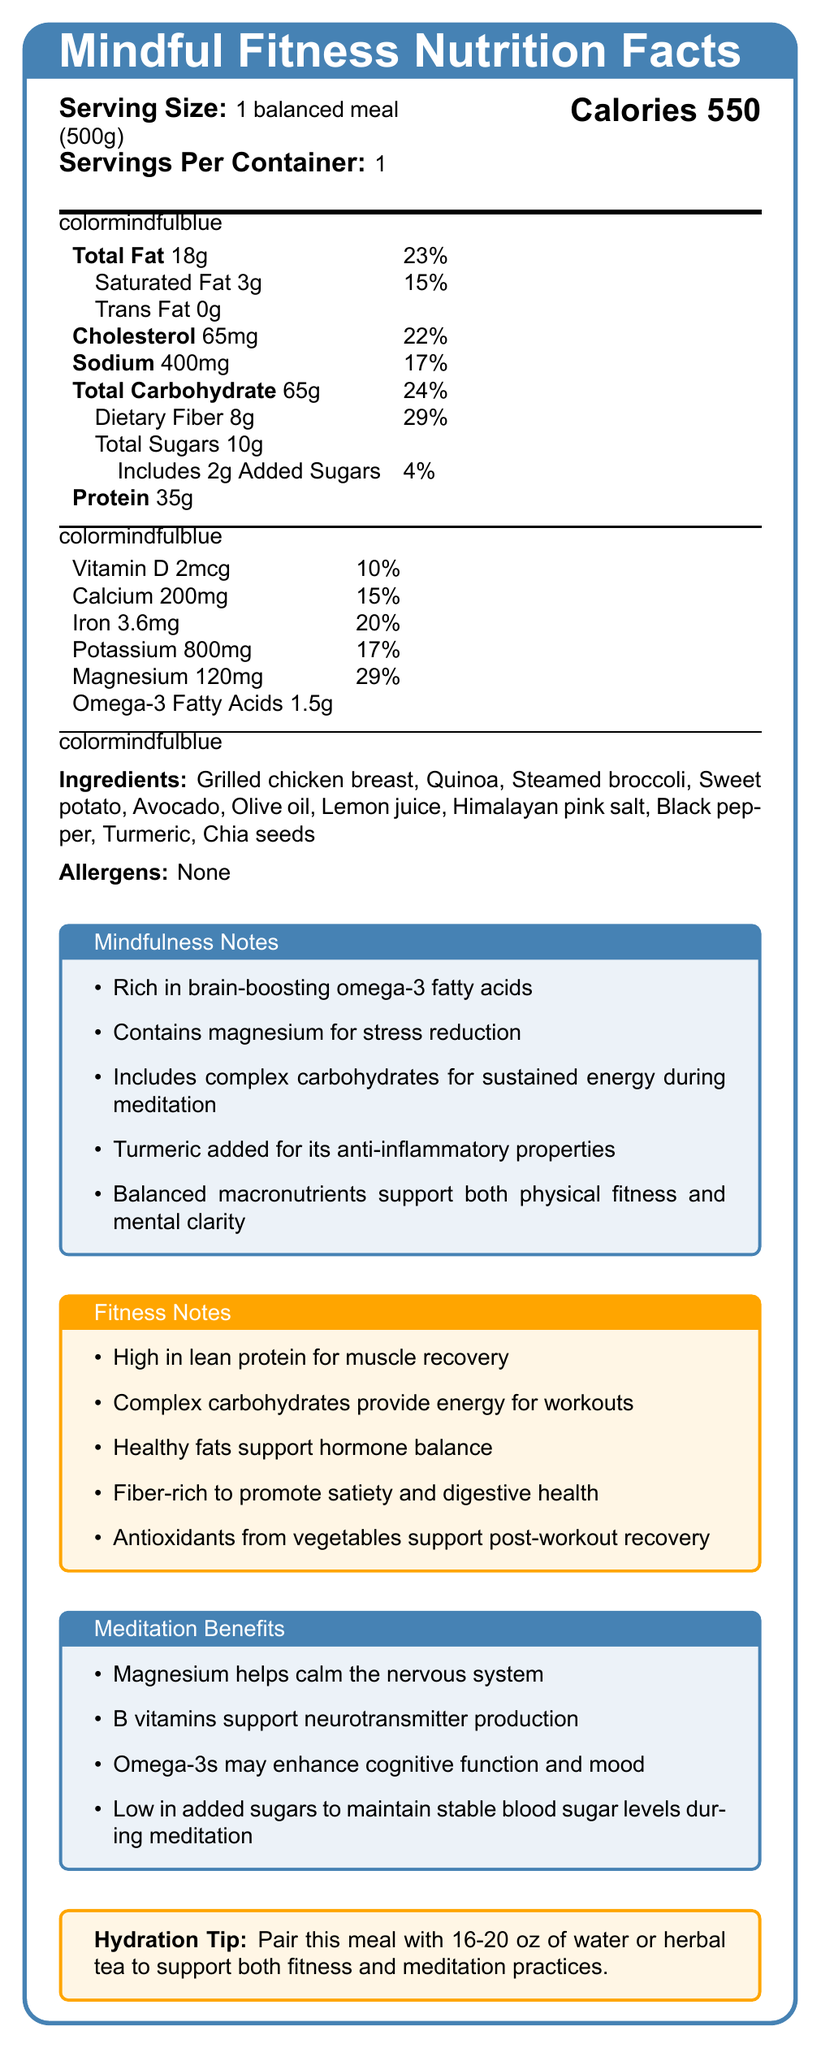what is the serving size of the meal? The document states the serving size as "1 balanced meal (500g)".
Answer: 1 balanced meal (500g) How many calories are in one serving? The document lists the calorie content at the top right.
Answer: 550 calories What percentage of daily iron does this meal provide? The document lists the iron content as "3.6mg" which is 20% of the daily value.
Answer: 20% How much protein does this meal contain? The document states the protein content is 35g.
Answer: 35g What are the main ingredients in this meal? The document lists these ingredients under the "Ingredients" section.
Answer: Grilled chicken breast, Quinoa, Steamed broccoli, Sweet potato, Avocado, Olive oil, Lemon juice, Himalayan pink salt, Black pepper, Turmeric, Chia seeds What is the percentage daily value of saturated fat in this meal? The document lists saturated fat as "3g" which is 15% of the daily value.
Answer: 15% What is the amount of omega-3 fatty acids in this meal? The document lists omega-3 fatty acids content.
Answer: 1.5g What hydration tip is given to pair with this meal? The hydration tip is stated at the bottom of the document.
Answer: Pair this meal with 16-20 oz of water or herbal tea to support both fitness and meditation practices. Which of the following benefits is mentioned under the "Fitness Notes"?    A. Magnesium helps calm the nervous system    B. High in lean protein for muscle recovery    C. Low in added sugars to maintain stable blood sugar levels    D. Rich in brain-boosting omega-3 fatty acids Under "Fitness Notes", "High in lean protein for muscle recovery" is mentioned.
Answer: B What is the percentage of daily value for dietary fiber?    I. 15%    II. 23%    III. 29% The document lists dietary fiber as "8g" which is 29% of the daily value.
Answer: III. 29% Is there any allergen listed for this meal? The document states "Allergens: None".
Answer: No Summarize the main idea of this document. The document includes comprehensive nutritional information, the ingredients used, and various benefit notes that highlight the advantages for fitness and meditation practices.
Answer: This document provides the nutrition facts label for a balanced meal tailored for clients practicing both fitness and meditation, including detailed nutritional content, ingredients, and notes on the benefits related to mindfulness, fitness, and meditation. How many other minerals besides iron are listed with their daily values? The document lists Vitamin D, Calcium, Potassium, and Magnesium with their respective daily values, in addition to iron.
Answer: Four Can the meal's calorie content be determined precisely from the document alone? The document clearly states the calories content as 550.
Answer: Yes What brand provides this balanced meal? The document does not provide any information about the brand or manufacturer of the meal.
Answer: Cannot be determined 